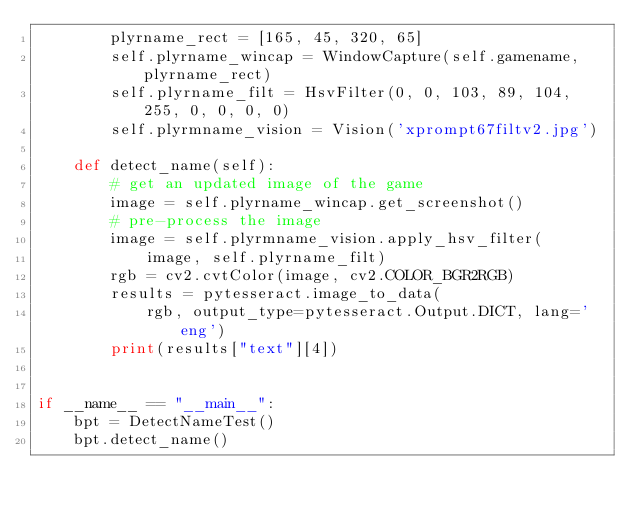Convert code to text. <code><loc_0><loc_0><loc_500><loc_500><_Python_>        plyrname_rect = [165, 45, 320, 65]
        self.plyrname_wincap = WindowCapture(self.gamename, plyrname_rect)
        self.plyrname_filt = HsvFilter(0, 0, 103, 89, 104, 255, 0, 0, 0, 0)
        self.plyrmname_vision = Vision('xprompt67filtv2.jpg')

    def detect_name(self):
        # get an updated image of the game
        image = self.plyrname_wincap.get_screenshot()
        # pre-process the image
        image = self.plyrmname_vision.apply_hsv_filter(
            image, self.plyrname_filt)
        rgb = cv2.cvtColor(image, cv2.COLOR_BGR2RGB)
        results = pytesseract.image_to_data(
            rgb, output_type=pytesseract.Output.DICT, lang='eng')
        print(results["text"][4])


if __name__ == "__main__":
    bpt = DetectNameTest()
    bpt.detect_name()
</code> 